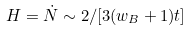<formula> <loc_0><loc_0><loc_500><loc_500>H = \dot { N } \sim 2 / [ 3 ( w _ { B } + 1 ) t ]</formula> 